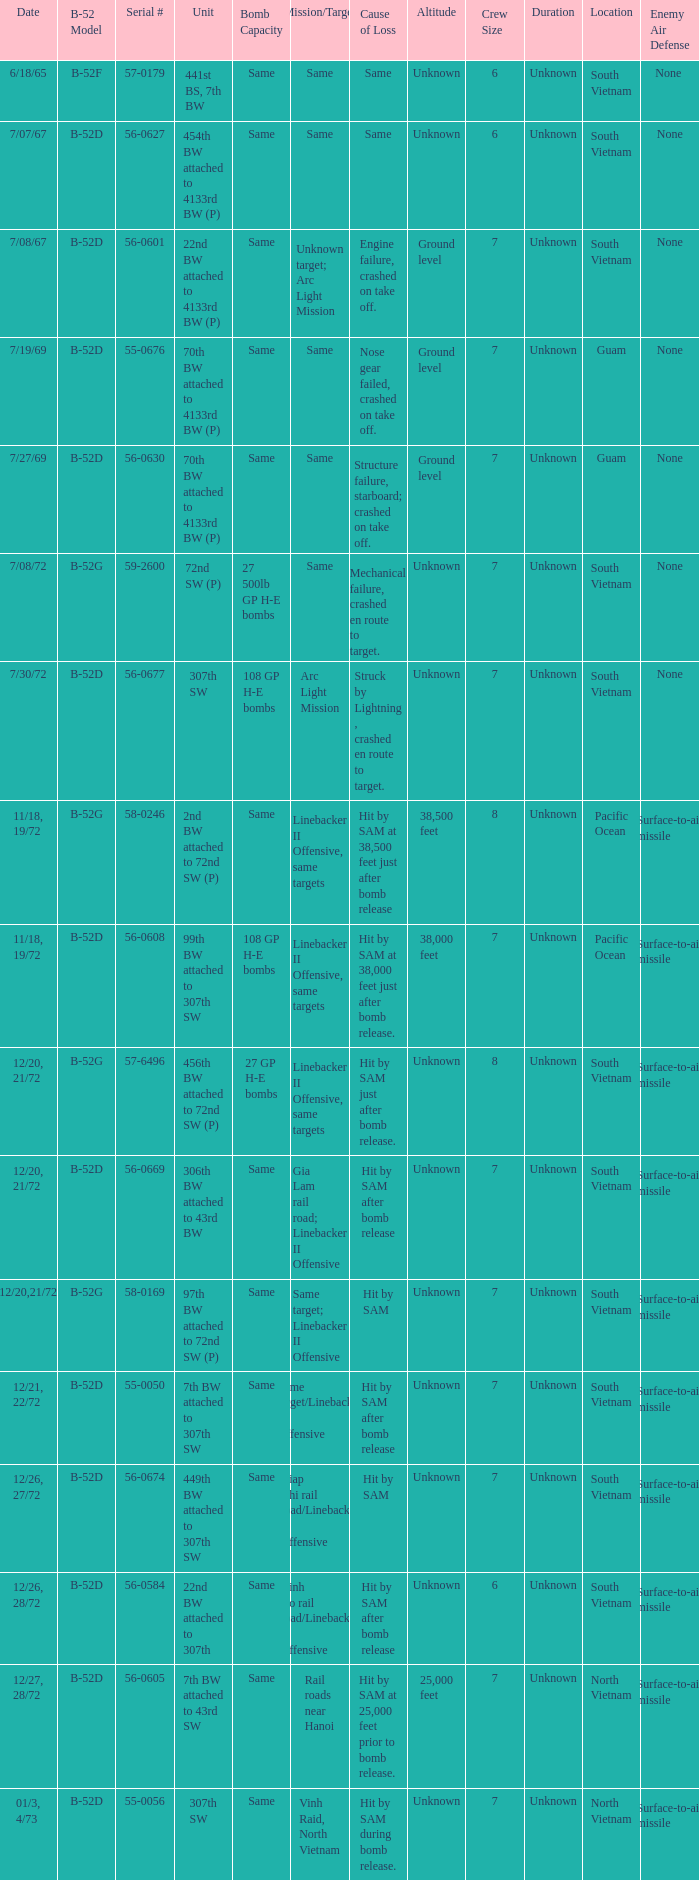When 7th bw attached to 43rd sw is the unit what is the b-52 model? B-52D. 